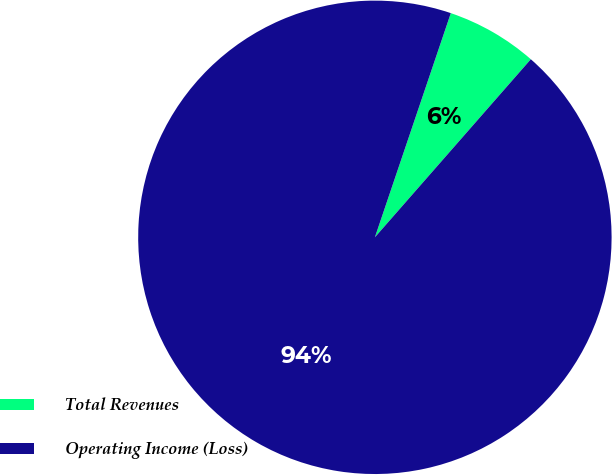Convert chart to OTSL. <chart><loc_0><loc_0><loc_500><loc_500><pie_chart><fcel>Total Revenues<fcel>Operating Income (Loss)<nl><fcel>6.25%<fcel>93.75%<nl></chart> 